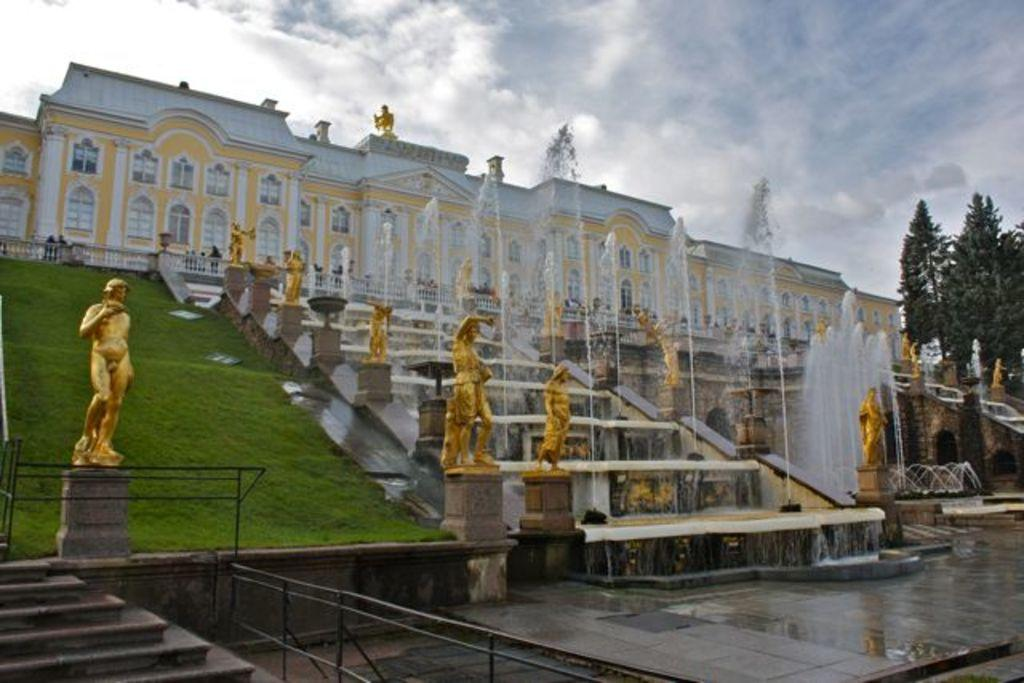What type of art is present in the image? There are sculptures in the image. What type of natural environment is depicted in the image? There are trees, water, and grass visible in the image. What can be seen in the background of the image? There is a building and the sky visible in the background of the image. What is the condition of the sky in the image? The sky is visible in the background of the image, and there are clouds present. Are there any letters being written by the trees in the image? There are no letters or writing present in the image; it features sculptures, trees, water, grass, a building, and clouds in the sky. Can you see a farm or any farm animals in the image? There is no farm or farm animals visible in the image; it features sculptures, trees, water, grass, a building, and clouds in the sky. 